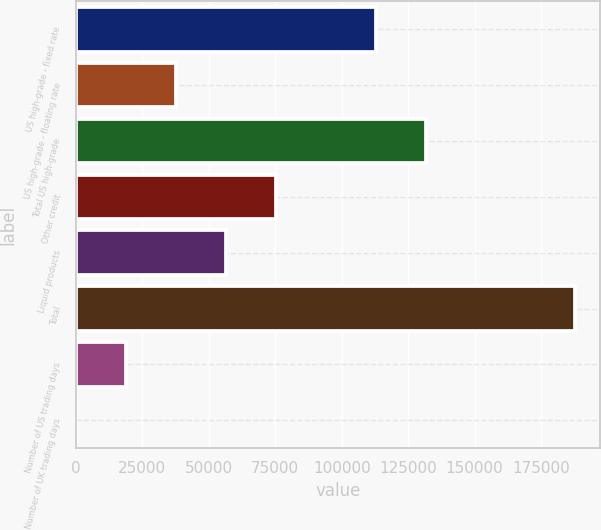Convert chart to OTSL. <chart><loc_0><loc_0><loc_500><loc_500><bar_chart><fcel>US high-grade - fixed rate<fcel>US high-grade - floating rate<fcel>Total US high-grade<fcel>Other credit<fcel>Liquid products<fcel>Total<fcel>Number of US trading days<fcel>Number of UK trading days<nl><fcel>112955<fcel>37587.6<fcel>131718<fcel>75113.2<fcel>56350.4<fcel>187690<fcel>18824.8<fcel>62<nl></chart> 